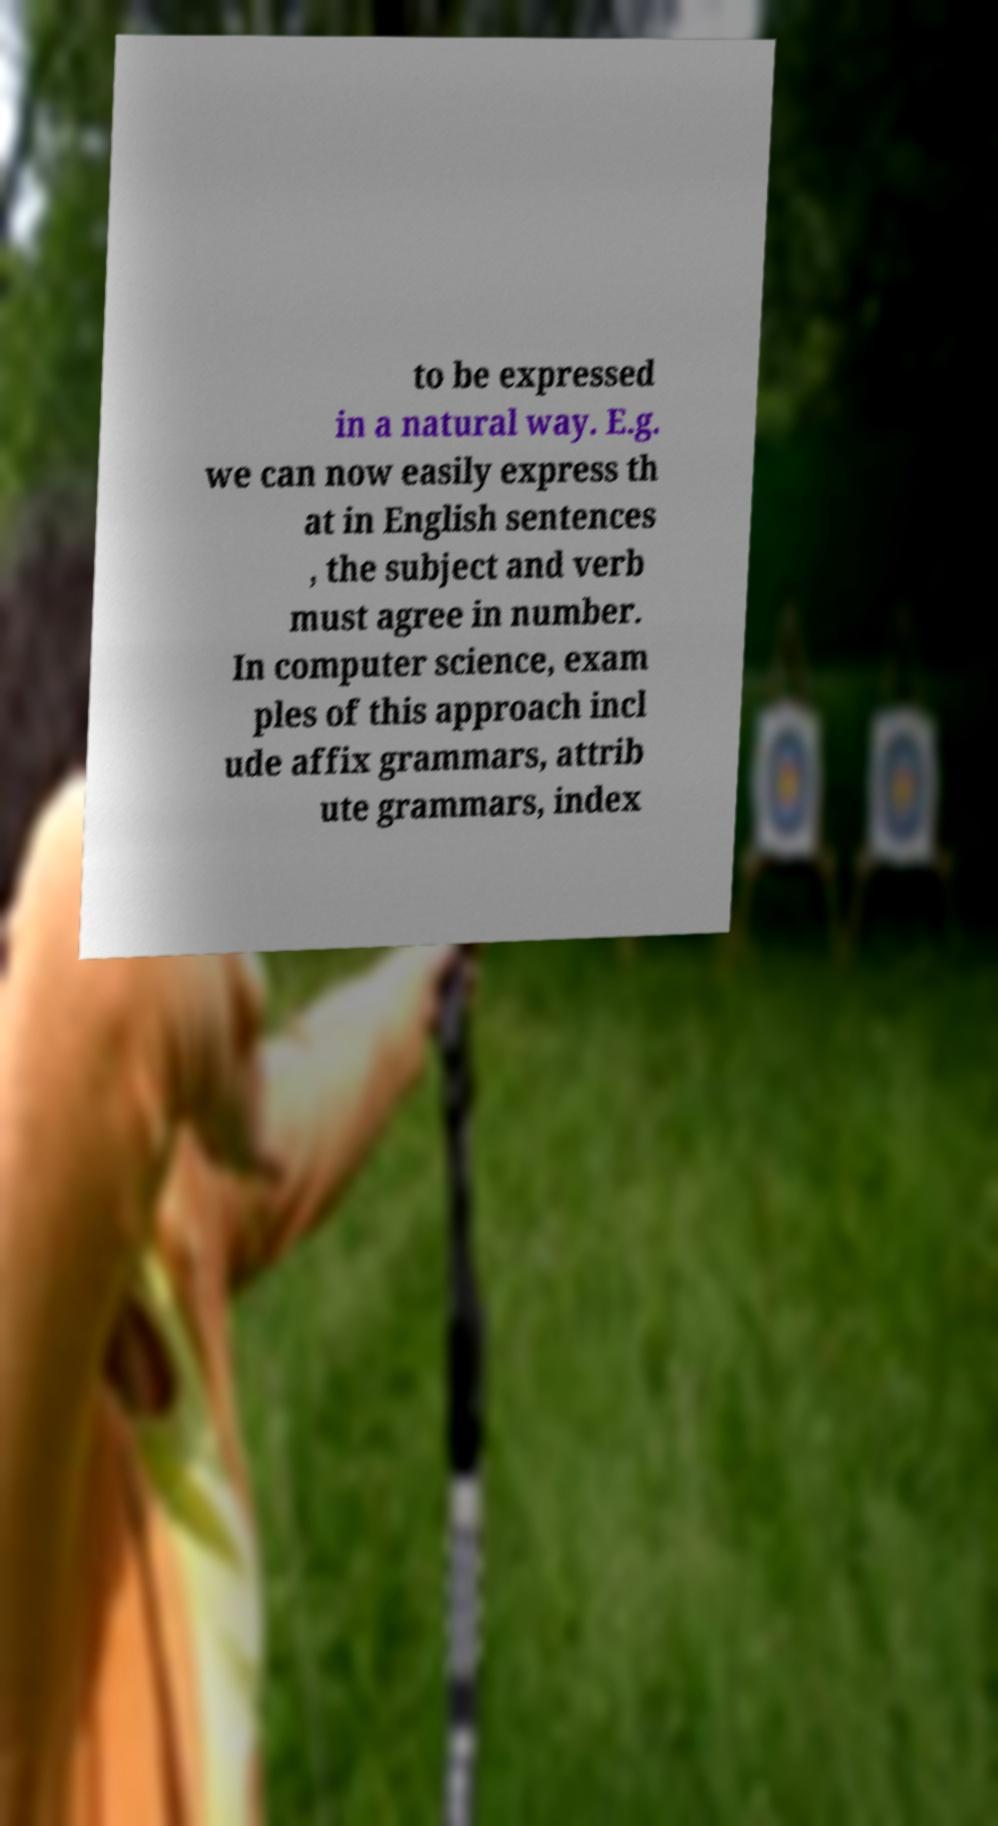I need the written content from this picture converted into text. Can you do that? to be expressed in a natural way. E.g. we can now easily express th at in English sentences , the subject and verb must agree in number. In computer science, exam ples of this approach incl ude affix grammars, attrib ute grammars, index 